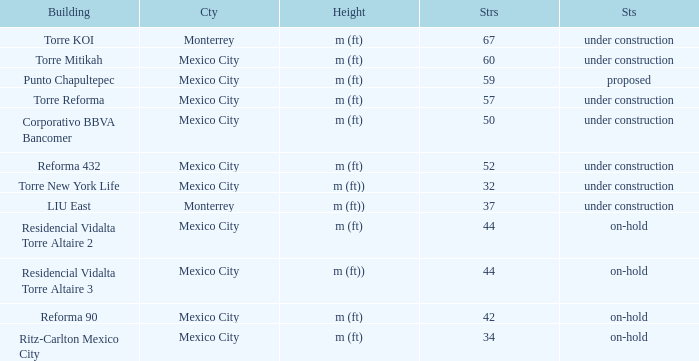How many stories is the torre reforma building? 1.0. 